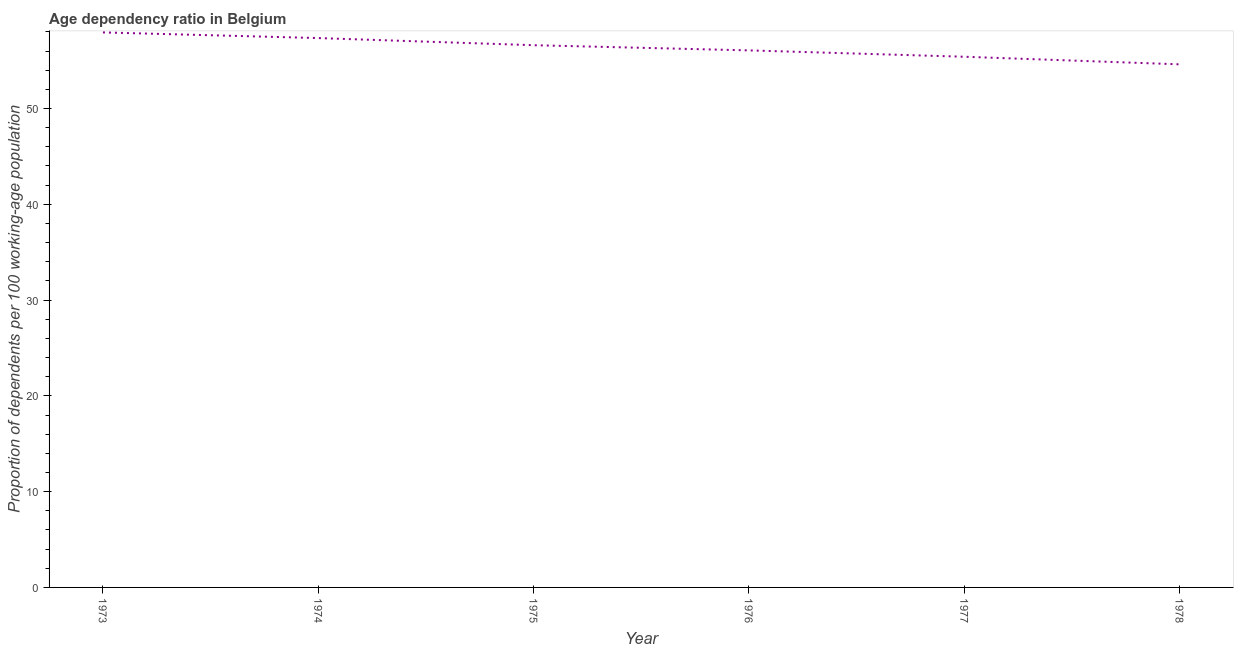What is the age dependency ratio in 1975?
Make the answer very short. 56.61. Across all years, what is the maximum age dependency ratio?
Keep it short and to the point. 57.94. Across all years, what is the minimum age dependency ratio?
Give a very brief answer. 54.61. In which year was the age dependency ratio maximum?
Give a very brief answer. 1973. In which year was the age dependency ratio minimum?
Provide a short and direct response. 1978. What is the sum of the age dependency ratio?
Offer a very short reply. 337.99. What is the difference between the age dependency ratio in 1973 and 1977?
Keep it short and to the point. 2.54. What is the average age dependency ratio per year?
Your answer should be very brief. 56.33. What is the median age dependency ratio?
Provide a short and direct response. 56.34. In how many years, is the age dependency ratio greater than 14 ?
Ensure brevity in your answer.  6. Do a majority of the years between 1977 and 1973 (inclusive) have age dependency ratio greater than 16 ?
Keep it short and to the point. Yes. What is the ratio of the age dependency ratio in 1974 to that in 1975?
Give a very brief answer. 1.01. Is the age dependency ratio in 1973 less than that in 1974?
Provide a short and direct response. No. What is the difference between the highest and the second highest age dependency ratio?
Provide a succinct answer. 0.59. Is the sum of the age dependency ratio in 1974 and 1978 greater than the maximum age dependency ratio across all years?
Provide a short and direct response. Yes. What is the difference between the highest and the lowest age dependency ratio?
Offer a very short reply. 3.33. Does the age dependency ratio monotonically increase over the years?
Make the answer very short. No. What is the difference between two consecutive major ticks on the Y-axis?
Provide a short and direct response. 10. Does the graph contain grids?
Make the answer very short. No. What is the title of the graph?
Provide a short and direct response. Age dependency ratio in Belgium. What is the label or title of the X-axis?
Ensure brevity in your answer.  Year. What is the label or title of the Y-axis?
Your answer should be very brief. Proportion of dependents per 100 working-age population. What is the Proportion of dependents per 100 working-age population in 1973?
Ensure brevity in your answer.  57.94. What is the Proportion of dependents per 100 working-age population in 1974?
Give a very brief answer. 57.35. What is the Proportion of dependents per 100 working-age population of 1975?
Offer a terse response. 56.61. What is the Proportion of dependents per 100 working-age population of 1976?
Give a very brief answer. 56.07. What is the Proportion of dependents per 100 working-age population in 1977?
Offer a very short reply. 55.4. What is the Proportion of dependents per 100 working-age population of 1978?
Provide a succinct answer. 54.61. What is the difference between the Proportion of dependents per 100 working-age population in 1973 and 1974?
Provide a succinct answer. 0.59. What is the difference between the Proportion of dependents per 100 working-age population in 1973 and 1975?
Make the answer very short. 1.33. What is the difference between the Proportion of dependents per 100 working-age population in 1973 and 1976?
Your response must be concise. 1.88. What is the difference between the Proportion of dependents per 100 working-age population in 1973 and 1977?
Your response must be concise. 2.54. What is the difference between the Proportion of dependents per 100 working-age population in 1973 and 1978?
Keep it short and to the point. 3.33. What is the difference between the Proportion of dependents per 100 working-age population in 1974 and 1975?
Offer a terse response. 0.75. What is the difference between the Proportion of dependents per 100 working-age population in 1974 and 1976?
Provide a short and direct response. 1.29. What is the difference between the Proportion of dependents per 100 working-age population in 1974 and 1977?
Your answer should be very brief. 1.95. What is the difference between the Proportion of dependents per 100 working-age population in 1974 and 1978?
Your answer should be very brief. 2.74. What is the difference between the Proportion of dependents per 100 working-age population in 1975 and 1976?
Provide a succinct answer. 0.54. What is the difference between the Proportion of dependents per 100 working-age population in 1975 and 1977?
Your answer should be compact. 1.21. What is the difference between the Proportion of dependents per 100 working-age population in 1975 and 1978?
Your answer should be very brief. 2. What is the difference between the Proportion of dependents per 100 working-age population in 1976 and 1977?
Provide a short and direct response. 0.66. What is the difference between the Proportion of dependents per 100 working-age population in 1976 and 1978?
Your answer should be compact. 1.46. What is the difference between the Proportion of dependents per 100 working-age population in 1977 and 1978?
Offer a very short reply. 0.79. What is the ratio of the Proportion of dependents per 100 working-age population in 1973 to that in 1974?
Your response must be concise. 1.01. What is the ratio of the Proportion of dependents per 100 working-age population in 1973 to that in 1975?
Offer a terse response. 1.02. What is the ratio of the Proportion of dependents per 100 working-age population in 1973 to that in 1976?
Provide a succinct answer. 1.03. What is the ratio of the Proportion of dependents per 100 working-age population in 1973 to that in 1977?
Make the answer very short. 1.05. What is the ratio of the Proportion of dependents per 100 working-age population in 1973 to that in 1978?
Offer a terse response. 1.06. What is the ratio of the Proportion of dependents per 100 working-age population in 1974 to that in 1977?
Provide a succinct answer. 1.03. What is the ratio of the Proportion of dependents per 100 working-age population in 1974 to that in 1978?
Offer a very short reply. 1.05. What is the ratio of the Proportion of dependents per 100 working-age population in 1975 to that in 1978?
Keep it short and to the point. 1.04. What is the ratio of the Proportion of dependents per 100 working-age population in 1976 to that in 1977?
Your answer should be very brief. 1.01. What is the ratio of the Proportion of dependents per 100 working-age population in 1976 to that in 1978?
Provide a succinct answer. 1.03. 